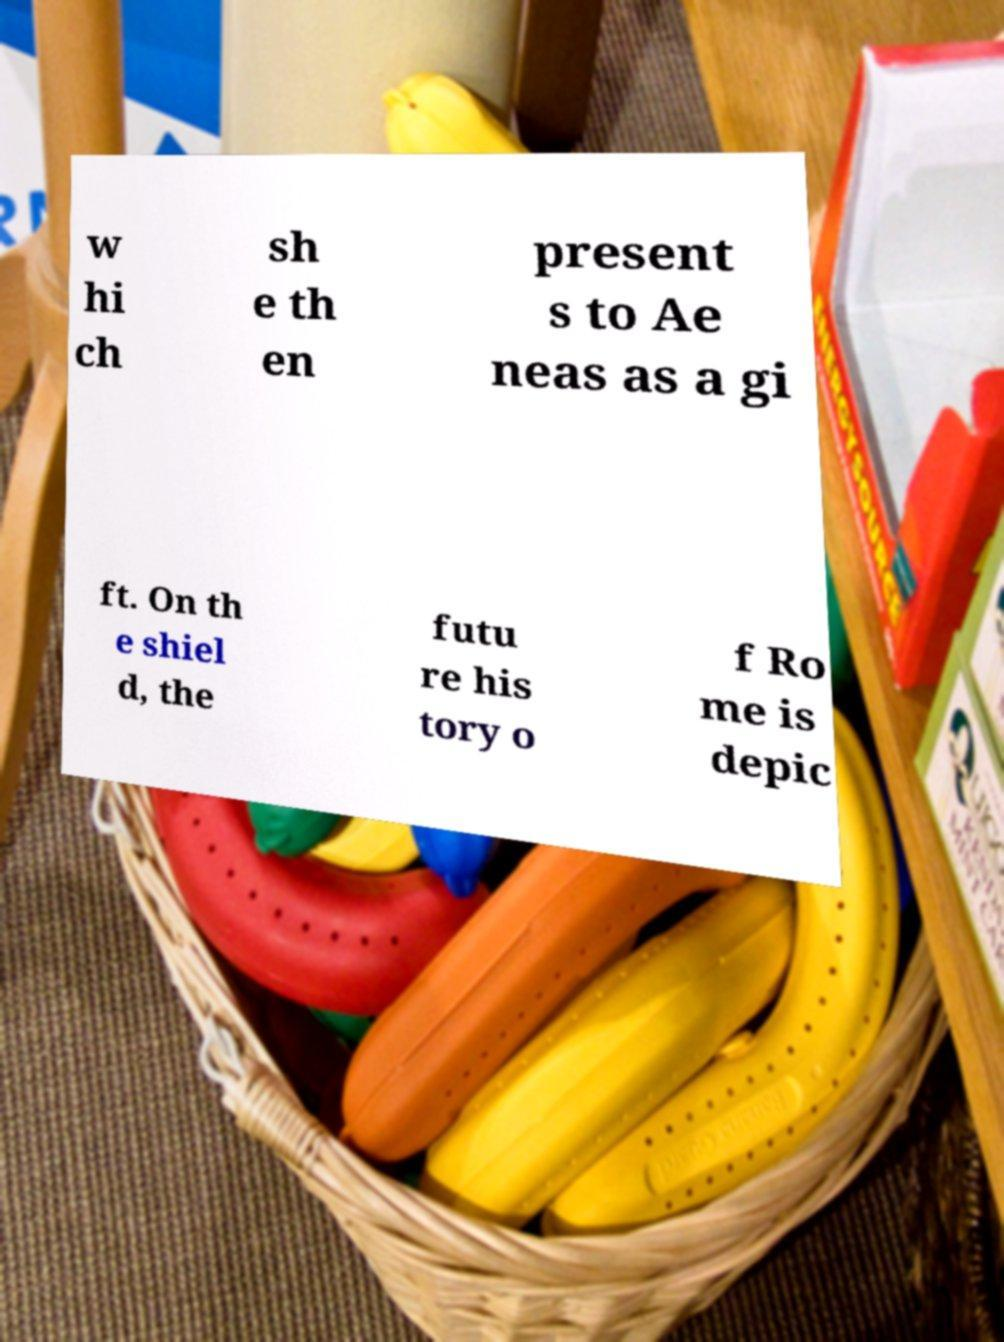Can you read and provide the text displayed in the image?This photo seems to have some interesting text. Can you extract and type it out for me? w hi ch sh e th en present s to Ae neas as a gi ft. On th e shiel d, the futu re his tory o f Ro me is depic 